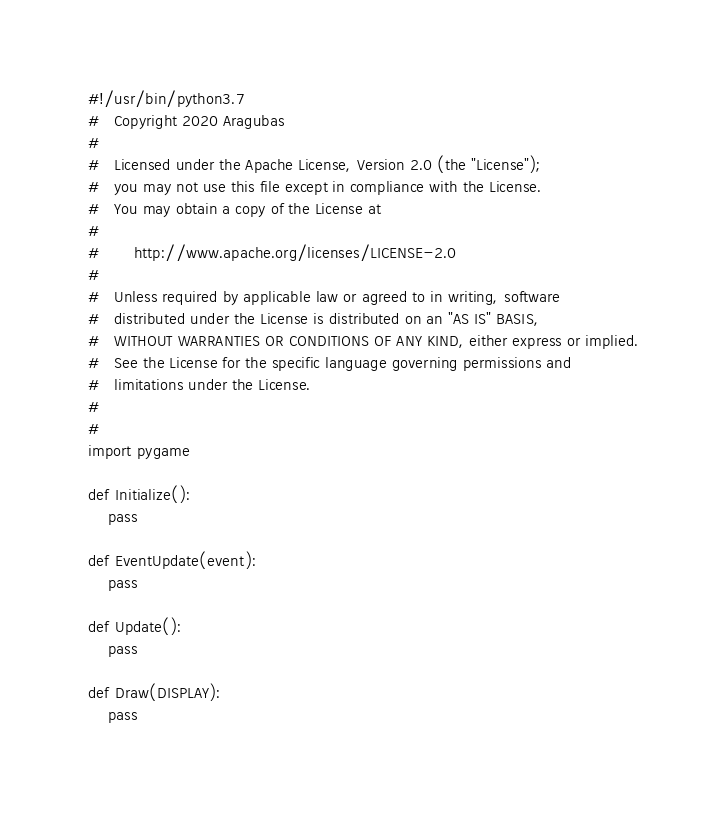Convert code to text. <code><loc_0><loc_0><loc_500><loc_500><_Python_>#!/usr/bin/python3.7
#   Copyright 2020 Aragubas
#
#   Licensed under the Apache License, Version 2.0 (the "License");
#   you may not use this file except in compliance with the License.
#   You may obtain a copy of the License at
#
#       http://www.apache.org/licenses/LICENSE-2.0
#
#   Unless required by applicable law or agreed to in writing, software
#   distributed under the License is distributed on an "AS IS" BASIS,
#   WITHOUT WARRANTIES OR CONDITIONS OF ANY KIND, either express or implied.
#   See the License for the specific language governing permissions and
#   limitations under the License.
#
#
import pygame

def Initialize():
    pass

def EventUpdate(event):
    pass

def Update():
    pass

def Draw(DISPLAY):
    pass</code> 